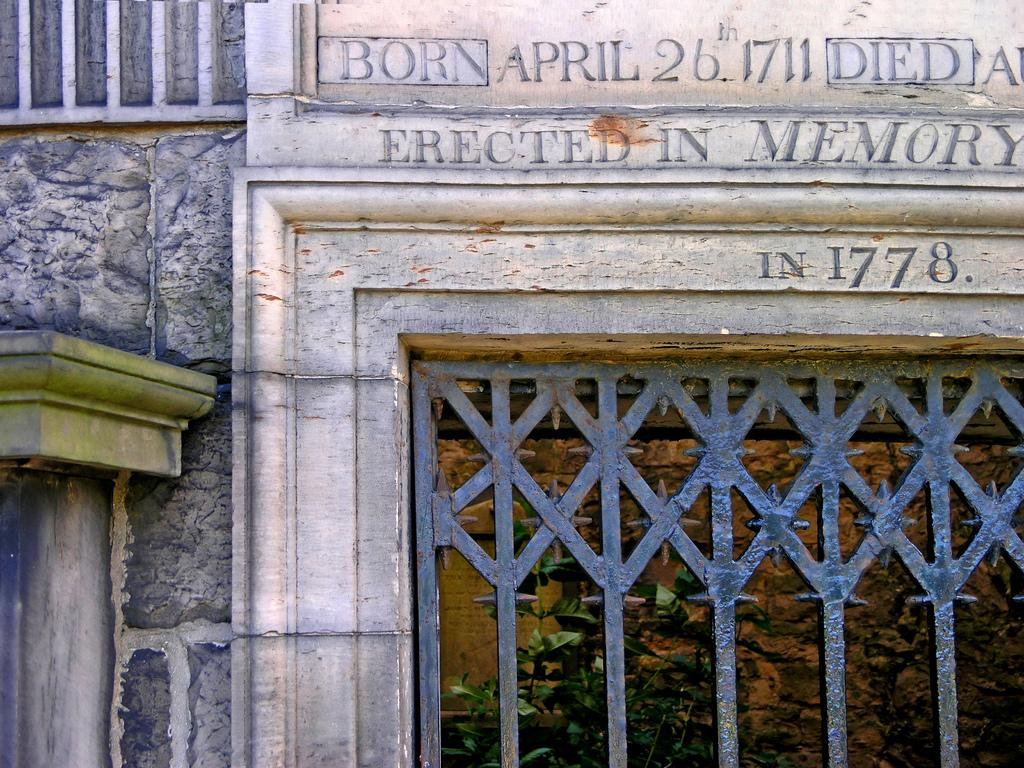What type of structure is visible in the image? There is a building in the image. What can be seen on the building? There is text on the building. What type of entrance is present in the image? There is an iron gate in the image. How many eyes can be seen on the building in the image? There are no eyes visible on the building in the image. What type of gardening tool is present in the image? There is no gardening tool, such as a rake, present in the image. 